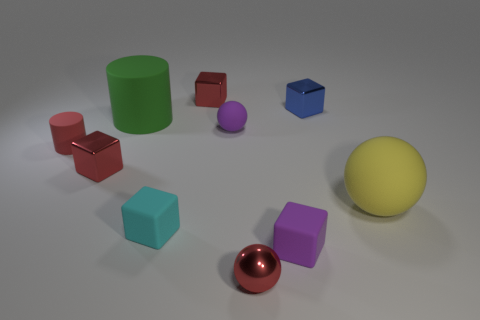The ball that is the same color as the small cylinder is what size?
Provide a short and direct response. Small. There is a purple thing that is in front of the big rubber sphere; what is its size?
Your answer should be compact. Small. How big is the matte sphere in front of the tiny red cylinder that is on the left side of the small red object in front of the cyan thing?
Your answer should be very brief. Large. There is a matte ball to the right of the small purple object behind the large sphere; what is its color?
Provide a short and direct response. Yellow. There is a cyan thing that is the same shape as the blue metallic object; what is its material?
Offer a very short reply. Rubber. Is there any other thing that is made of the same material as the blue cube?
Your answer should be compact. Yes. There is a tiny red ball; are there any tiny things in front of it?
Offer a terse response. No. How many yellow rubber things are there?
Make the answer very short. 1. How many yellow rubber objects are behind the tiny red shiny cube that is behind the big green matte cylinder?
Make the answer very short. 0. There is a tiny matte cylinder; does it have the same color as the shiny thing left of the big green matte thing?
Your answer should be very brief. Yes. 